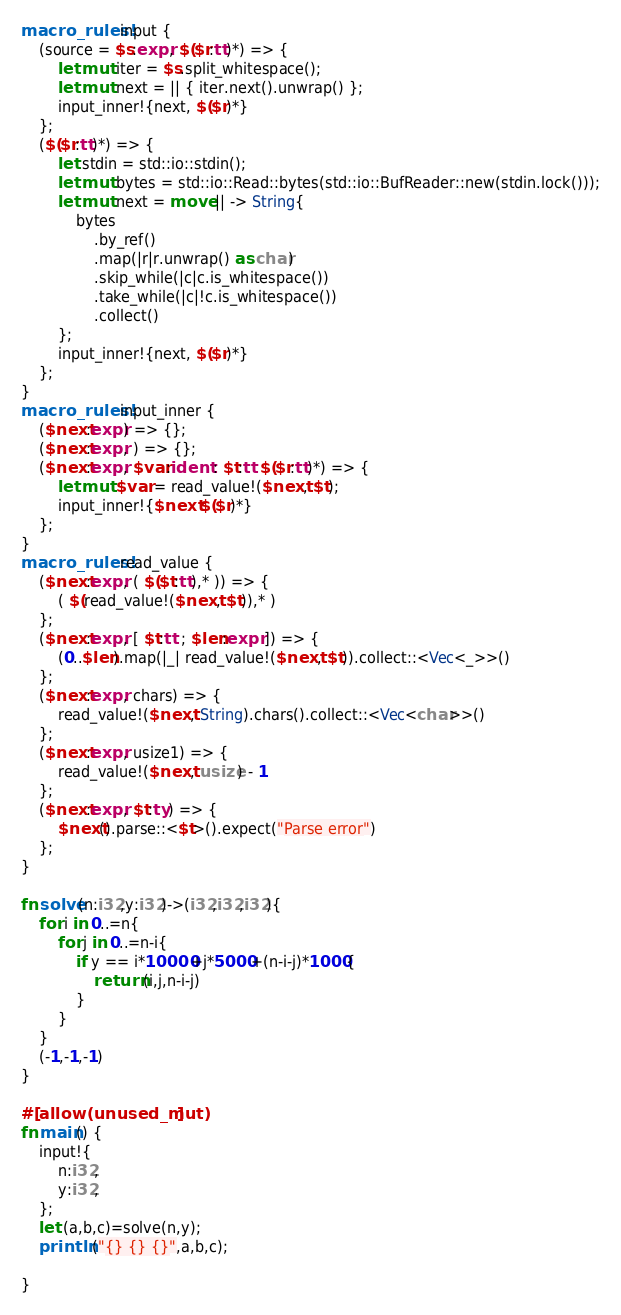Convert code to text. <code><loc_0><loc_0><loc_500><loc_500><_Rust_>macro_rules! input {
    (source = $s:expr, $($r:tt)*) => {
        let mut iter = $s.split_whitespace();
        let mut next = || { iter.next().unwrap() };
        input_inner!{next, $($r)*}
    };
    ($($r:tt)*) => {
        let stdin = std::io::stdin();
        let mut bytes = std::io::Read::bytes(std::io::BufReader::new(stdin.lock()));
        let mut next = move || -> String{
            bytes
                .by_ref()
                .map(|r|r.unwrap() as char)
                .skip_while(|c|c.is_whitespace())
                .take_while(|c|!c.is_whitespace())
                .collect()
        };
        input_inner!{next, $($r)*}
    };
}
macro_rules! input_inner {
    ($next:expr) => {};
    ($next:expr, ) => {};
    ($next:expr, $var:ident : $t:tt $($r:tt)*) => {
        let mut $var = read_value!($next, $t);
        input_inner!{$next $($r)*}
    };
}
macro_rules! read_value {
    ($next:expr, ( $($t:tt),* )) => {
        ( $(read_value!($next, $t)),* )
    };
    ($next:expr, [ $t:tt ; $len:expr ]) => {
        (0..$len).map(|_| read_value!($next, $t)).collect::<Vec<_>>()
    };
    ($next:expr, chars) => {
        read_value!($next, String).chars().collect::<Vec<char>>()
    };
    ($next:expr, usize1) => {
        read_value!($next, usize) - 1
    };
    ($next:expr, $t:ty) => {
        $next().parse::<$t>().expect("Parse error")
    };
}

fn solve(n:i32,y:i32)->(i32,i32,i32){
    for i in 0..=n{
        for j in 0..=n-i{
            if y == i*10000+j*5000+(n-i-j)*1000{
                return (i,j,n-i-j)
            }
        }
    }
    (-1,-1,-1)
}

#[allow(unused_mut)]
fn main() {
    input!{
        n:i32,
        y:i32,
    };
    let (a,b,c)=solve(n,y);
    println!("{} {} {}",a,b,c);

}
</code> 